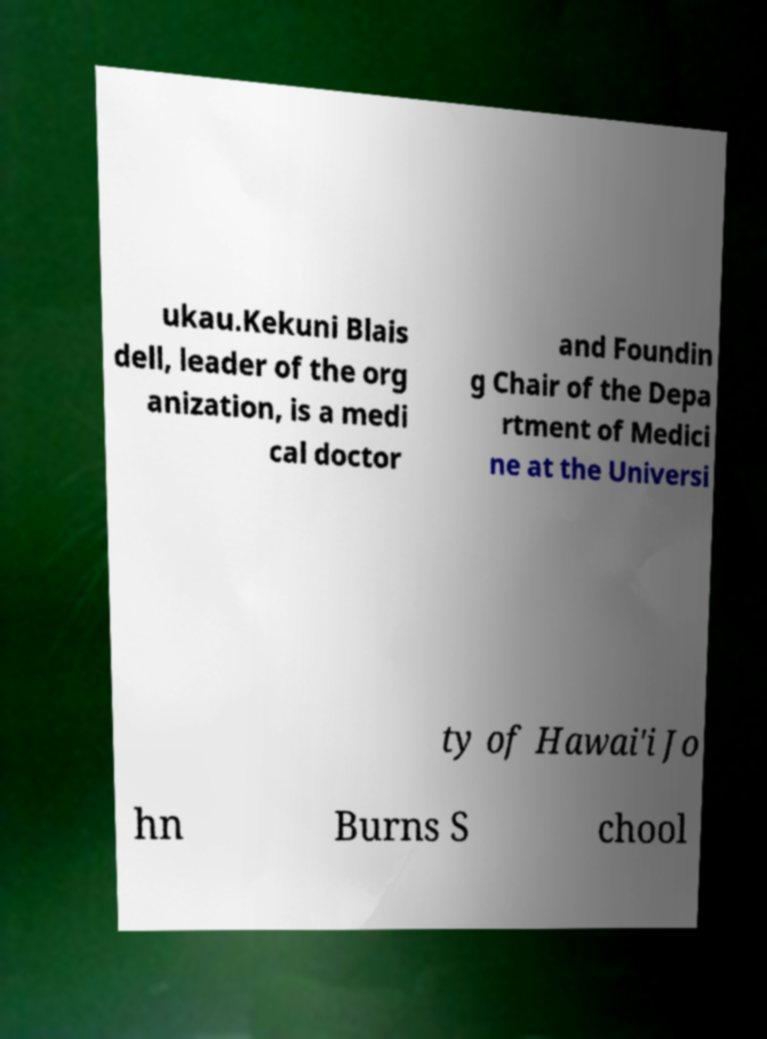Can you accurately transcribe the text from the provided image for me? ukau.Kekuni Blais dell, leader of the org anization, is a medi cal doctor and Foundin g Chair of the Depa rtment of Medici ne at the Universi ty of Hawai'i Jo hn Burns S chool 